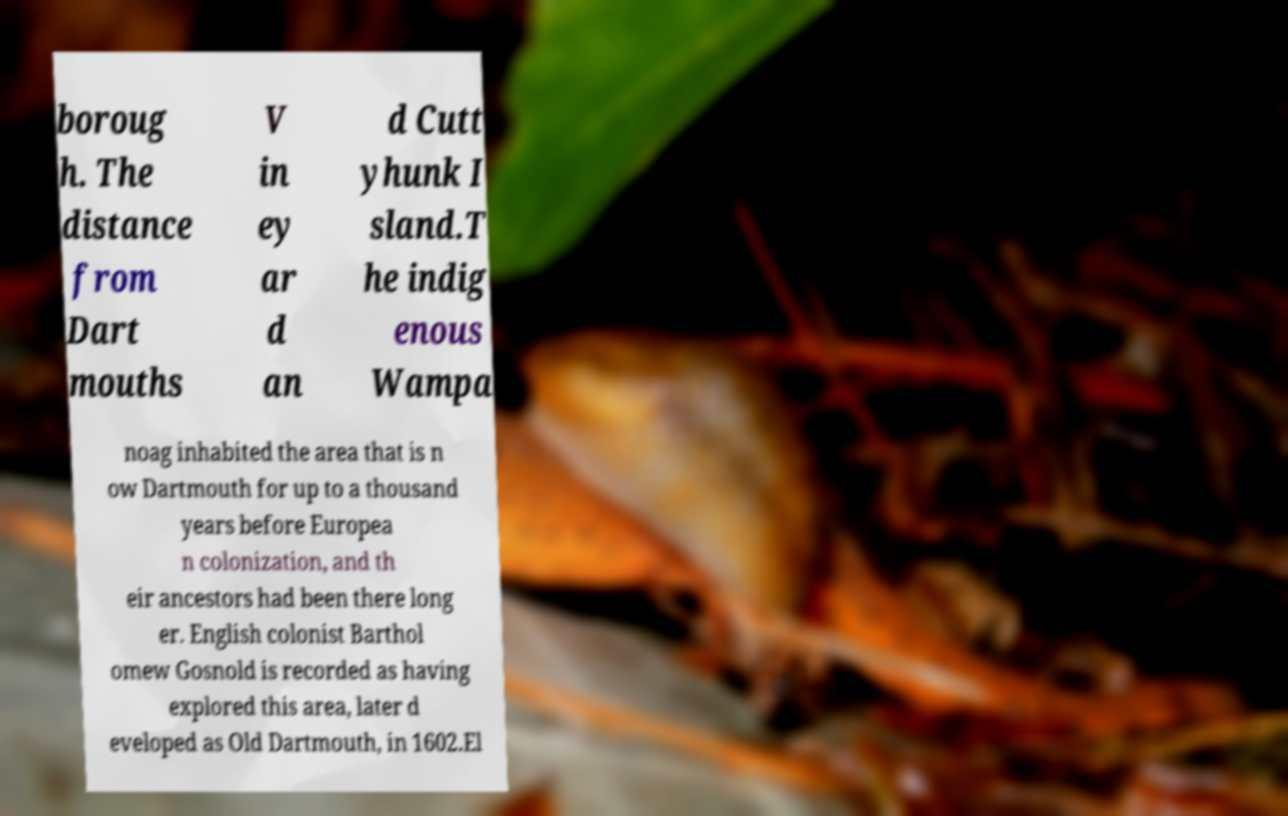I need the written content from this picture converted into text. Can you do that? boroug h. The distance from Dart mouths V in ey ar d an d Cutt yhunk I sland.T he indig enous Wampa noag inhabited the area that is n ow Dartmouth for up to a thousand years before Europea n colonization, and th eir ancestors had been there long er. English colonist Barthol omew Gosnold is recorded as having explored this area, later d eveloped as Old Dartmouth, in 1602.El 